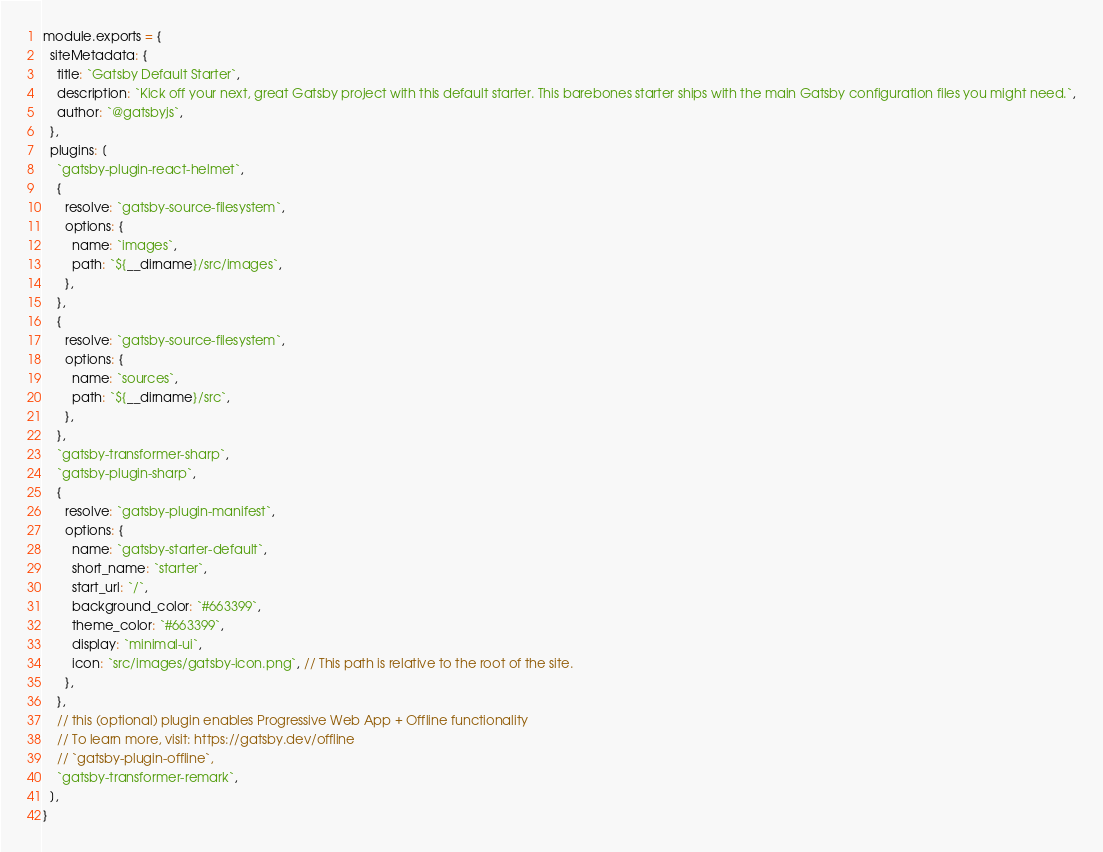Convert code to text. <code><loc_0><loc_0><loc_500><loc_500><_JavaScript_>module.exports = {
  siteMetadata: {
    title: `Gatsby Default Starter`,
    description: `Kick off your next, great Gatsby project with this default starter. This barebones starter ships with the main Gatsby configuration files you might need.`,
    author: `@gatsbyjs`,
  },
  plugins: [
    `gatsby-plugin-react-helmet`,
    {
      resolve: `gatsby-source-filesystem`,
      options: {
        name: `images`,
        path: `${__dirname}/src/images`,
      },
    },
    {
      resolve: `gatsby-source-filesystem`,
      options: {
        name: `sources`,
        path: `${__dirname}/src`,
      },
    },
    `gatsby-transformer-sharp`,
    `gatsby-plugin-sharp`,
    {
      resolve: `gatsby-plugin-manifest`,
      options: {
        name: `gatsby-starter-default`,
        short_name: `starter`,
        start_url: `/`,
        background_color: `#663399`,
        theme_color: `#663399`,
        display: `minimal-ui`,
        icon: `src/images/gatsby-icon.png`, // This path is relative to the root of the site.
      },
    },
    // this (optional) plugin enables Progressive Web App + Offline functionality
    // To learn more, visit: https://gatsby.dev/offline
    // `gatsby-plugin-offline`,
    `gatsby-transformer-remark`,
  ],
}
</code> 